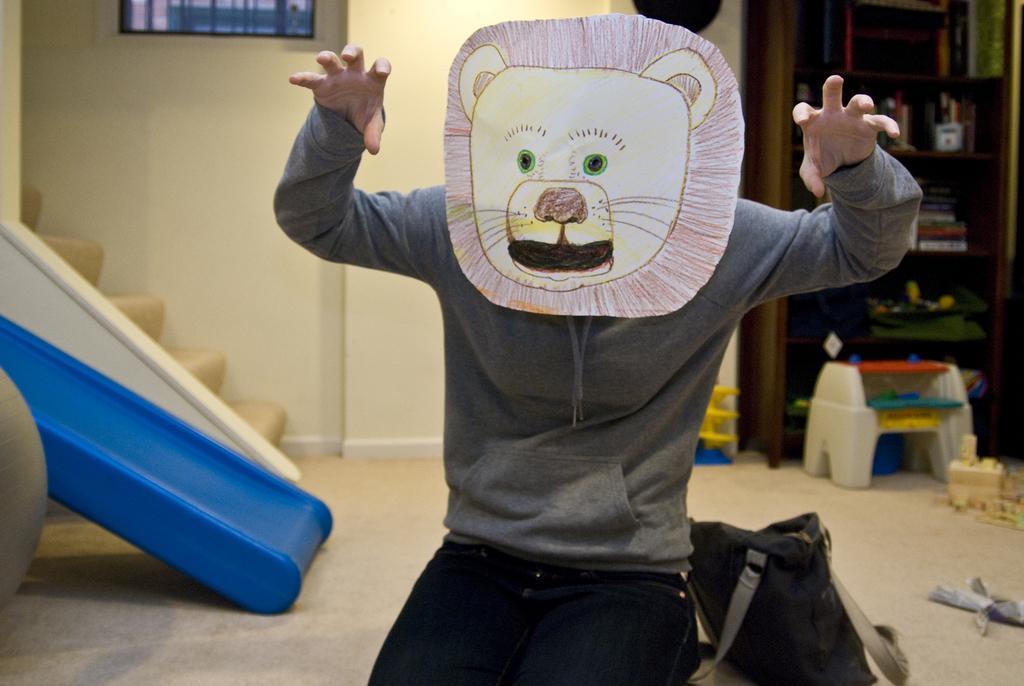In one or two sentences, can you explain what this image depicts? In this image we can see a person wearing a mask, there is a cupboard with books, bottles and some other objects, also we can see a staircase and a photo frame on the wall, there is a bag and some other objects on the floor. 